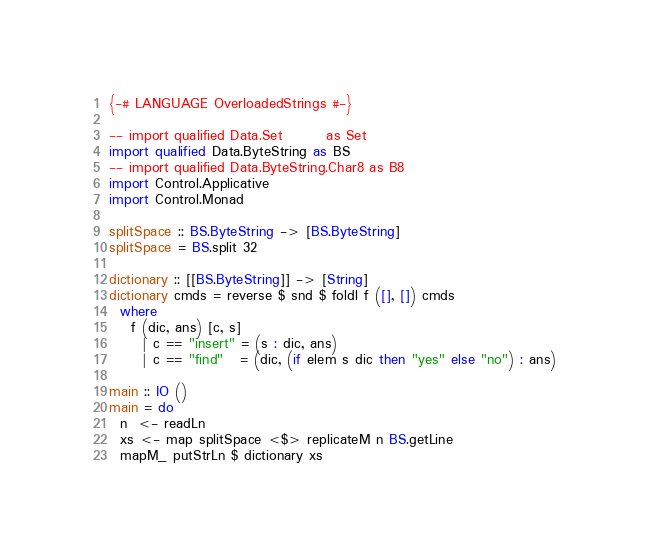Convert code to text. <code><loc_0><loc_0><loc_500><loc_500><_Haskell_>{-# LANGUAGE OverloadedStrings #-}

-- import qualified Data.Set        as Set
import qualified Data.ByteString as BS
-- import qualified Data.ByteString.Char8 as B8
import Control.Applicative
import Control.Monad

splitSpace :: BS.ByteString -> [BS.ByteString]
splitSpace = BS.split 32

dictionary :: [[BS.ByteString]] -> [String]
dictionary cmds = reverse $ snd $ foldl f ([], []) cmds
  where
    f (dic, ans) [c, s]
      | c == "insert" = (s : dic, ans)
      | c == "find"   = (dic, (if elem s dic then "yes" else "no") : ans)

main :: IO ()
main = do
  n  <- readLn
  xs <- map splitSpace <$> replicateM n BS.getLine
  mapM_ putStrLn $ dictionary xs

</code> 